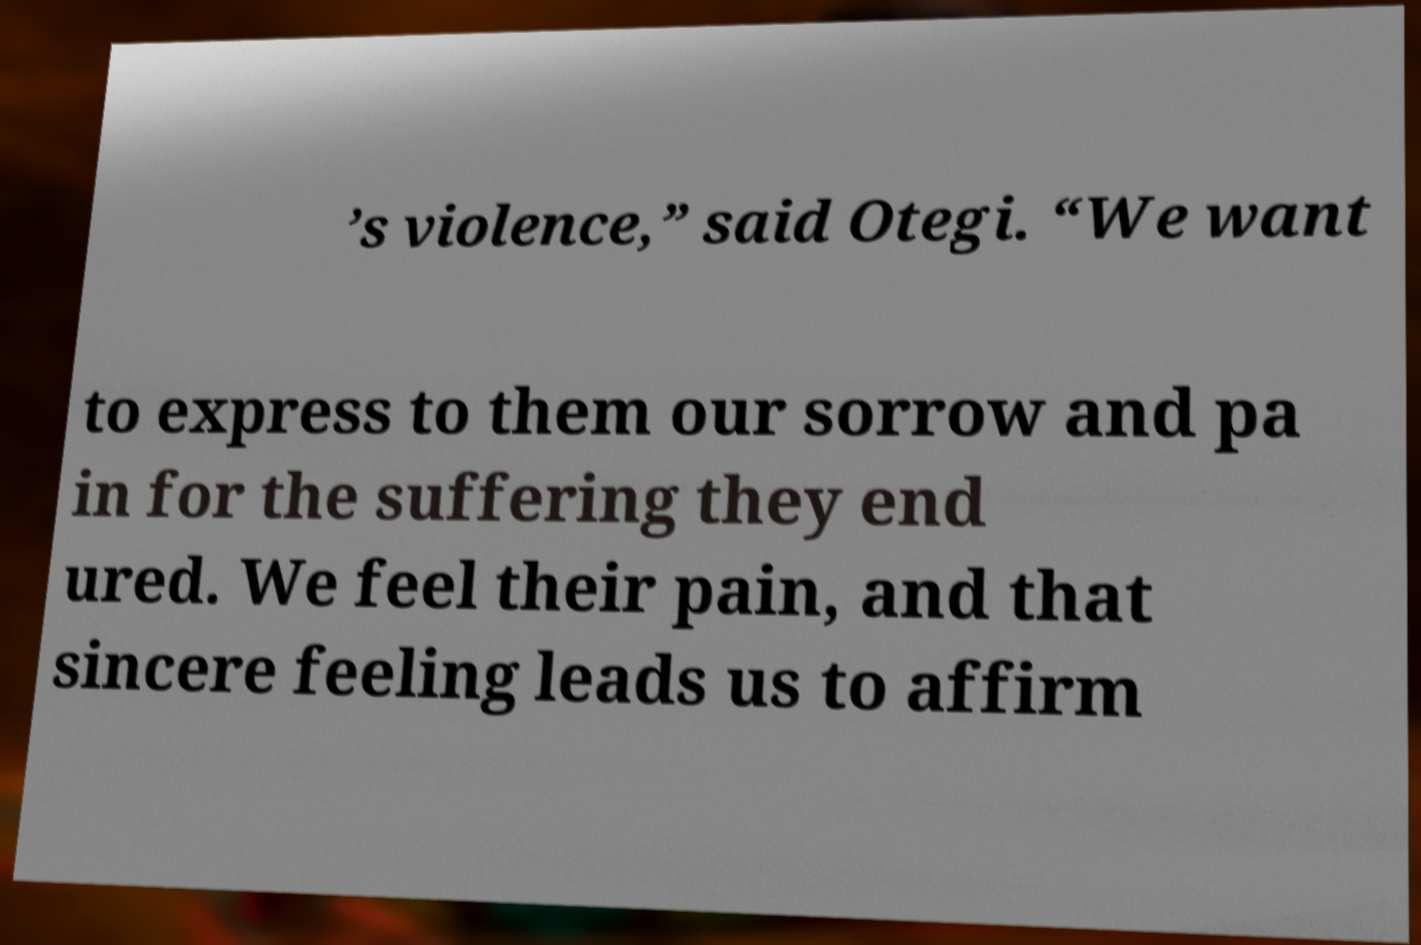There's text embedded in this image that I need extracted. Can you transcribe it verbatim? ’s violence,” said Otegi. “We want to express to them our sorrow and pa in for the suffering they end ured. We feel their pain, and that sincere feeling leads us to affirm 